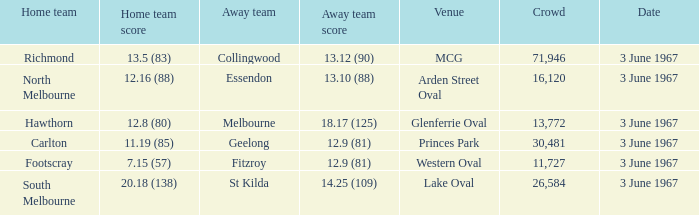What was Hawthorn's score as the home team? 12.8 (80). 